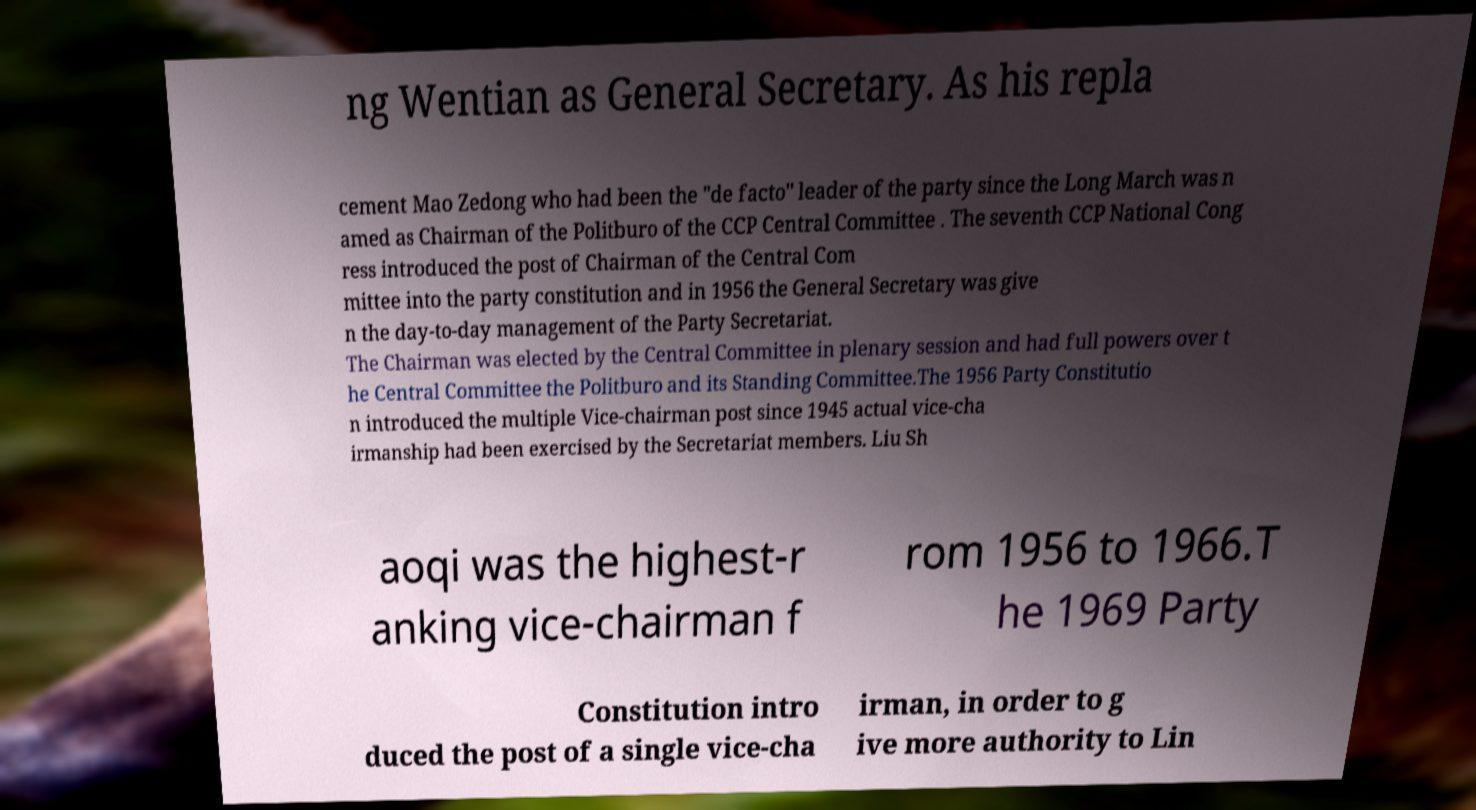What messages or text are displayed in this image? I need them in a readable, typed format. ng Wentian as General Secretary. As his repla cement Mao Zedong who had been the "de facto" leader of the party since the Long March was n amed as Chairman of the Politburo of the CCP Central Committee . The seventh CCP National Cong ress introduced the post of Chairman of the Central Com mittee into the party constitution and in 1956 the General Secretary was give n the day-to-day management of the Party Secretariat. The Chairman was elected by the Central Committee in plenary session and had full powers over t he Central Committee the Politburo and its Standing Committee.The 1956 Party Constitutio n introduced the multiple Vice-chairman post since 1945 actual vice-cha irmanship had been exercised by the Secretariat members. Liu Sh aoqi was the highest-r anking vice-chairman f rom 1956 to 1966.T he 1969 Party Constitution intro duced the post of a single vice-cha irman, in order to g ive more authority to Lin 